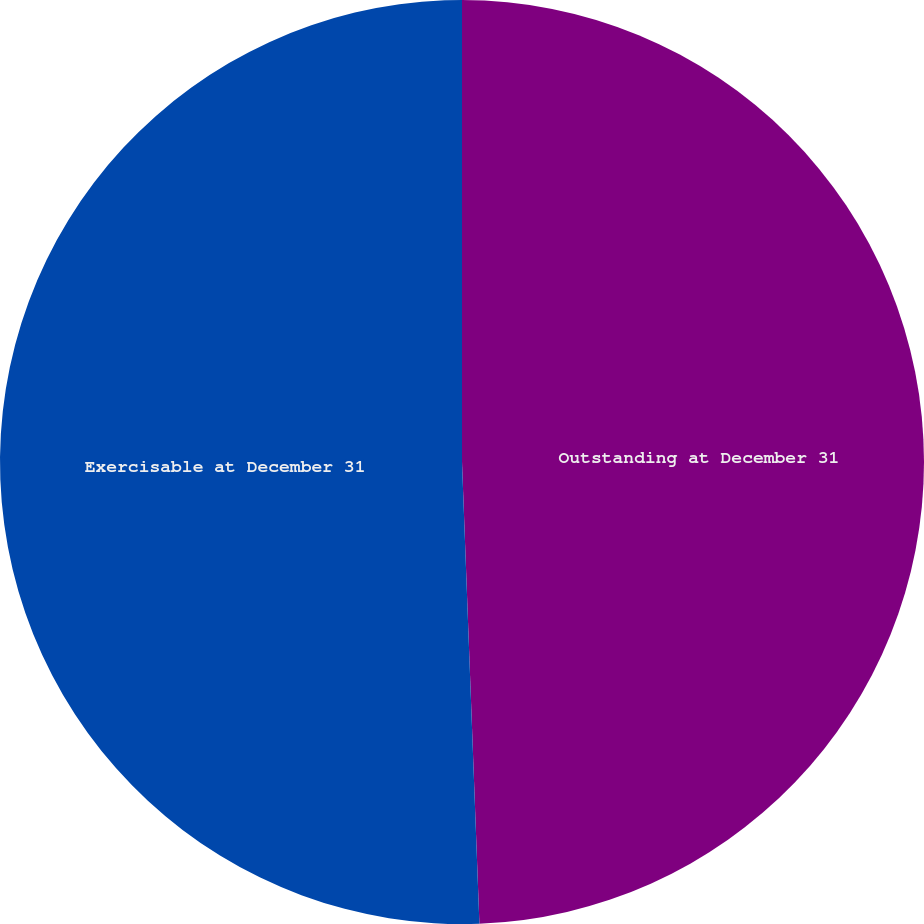Convert chart. <chart><loc_0><loc_0><loc_500><loc_500><pie_chart><fcel>Outstanding at December 31<fcel>Exercisable at December 31<nl><fcel>49.4%<fcel>50.6%<nl></chart> 